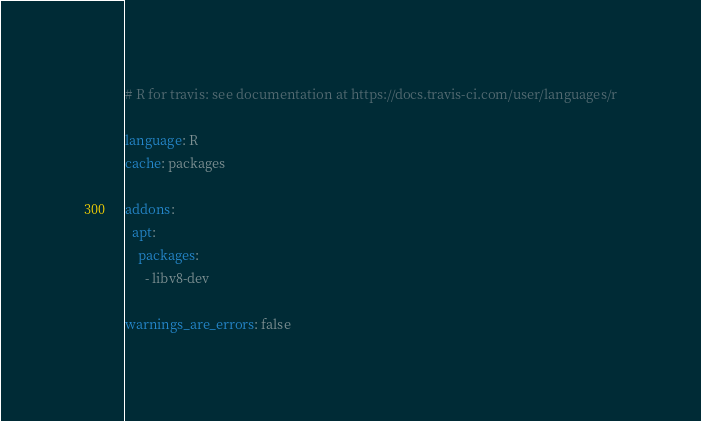<code> <loc_0><loc_0><loc_500><loc_500><_YAML_># R for travis: see documentation at https://docs.travis-ci.com/user/languages/r

language: R
cache: packages

addons:
  apt:
    packages:
      - libv8-dev

warnings_are_errors: false
</code> 